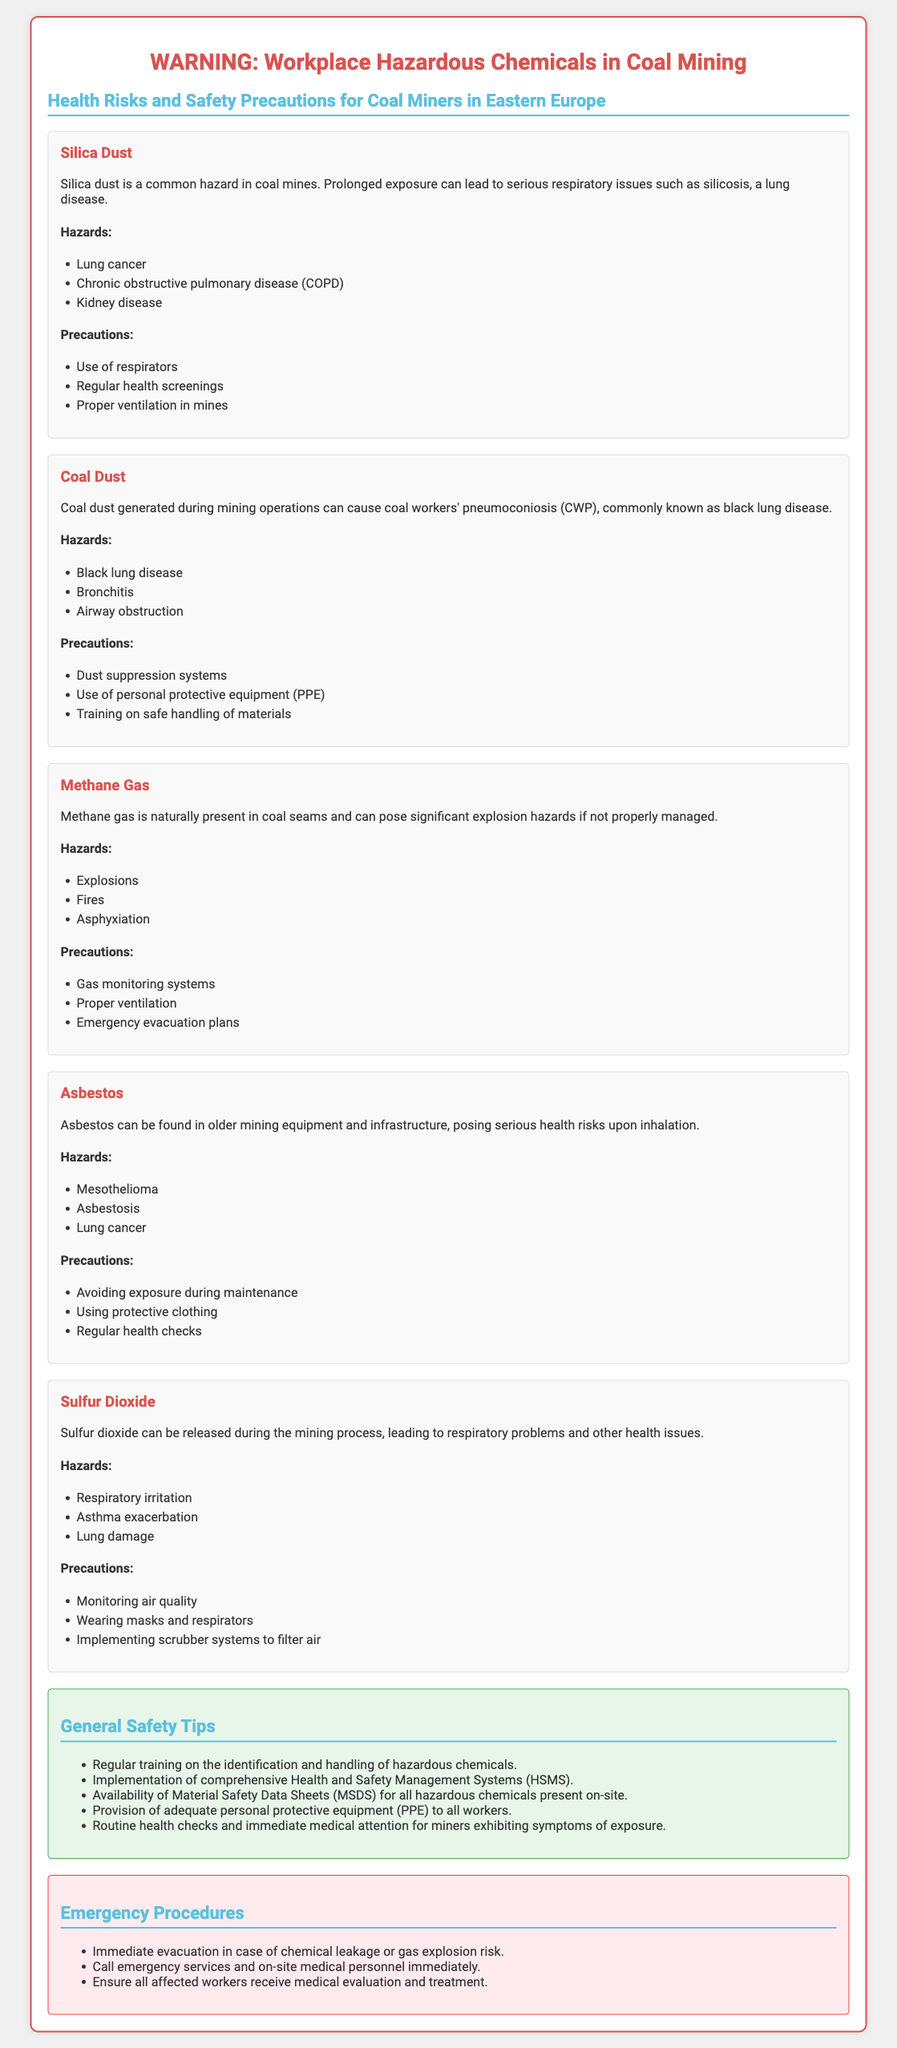What is the title of the warning label? The title is prominently displayed at the top of the document and sets the context for the hazardous chemicals involved.
Answer: WARNING: Workplace Hazardous Chemicals in Coal Mining What is a health risk associated with silica dust? The document lists multiple health risks related to silica dust, one of which is identified explicitly.
Answer: Lung cancer What precaution is recommended for coal dust exposure? The document contains a section on precautions specifically for coal dust, which includes key safety measures.
Answer: Dust suppression systems What gas poses explosion hazards in coal mines? Information in the document identifies a specific gas known for its explosive potential when not properly managed.
Answer: Methane gas What is a general safety tip provided in the document? This tip is one of several highlighted in the document emphasizing the importance of safety practices for coal miners.
Answer: Regular training on the identification and handling of hazardous chemicals Which disease is associated with coal workers' pneumoconiosis? The document refers to a specific condition that coal miners may develop due to exposure to dust.
Answer: Black lung disease What is the purpose of material safety data sheets (MSDS)? The document states the importance of having these sheets available for safety and information on hazardous chemicals.
Answer: Availability of Material Safety Data Sheets (MSDS) What should be done immediately in case of a gas explosion risk? The document outlines emergency procedures and actions to be taken during such incidents.
Answer: Immediate evacuation 